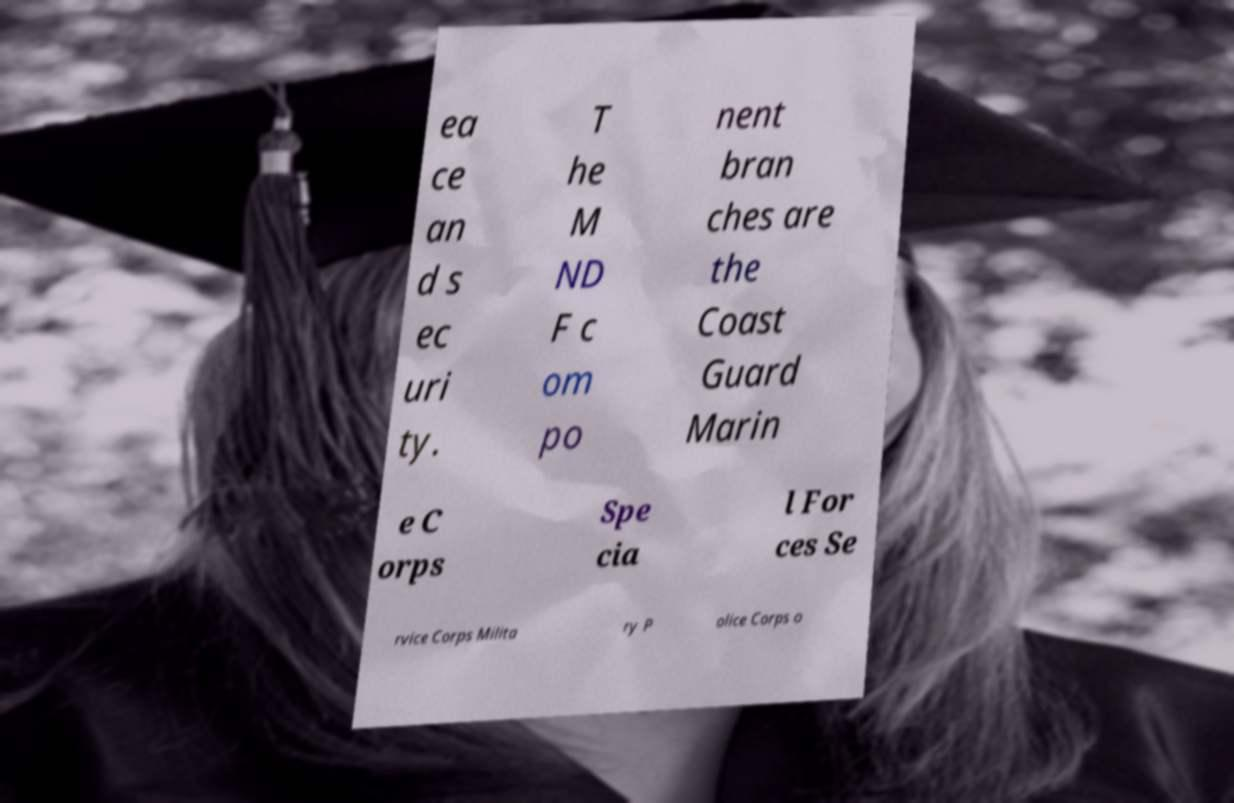Could you assist in decoding the text presented in this image and type it out clearly? ea ce an d s ec uri ty. T he M ND F c om po nent bran ches are the Coast Guard Marin e C orps Spe cia l For ces Se rvice Corps Milita ry P olice Corps o 